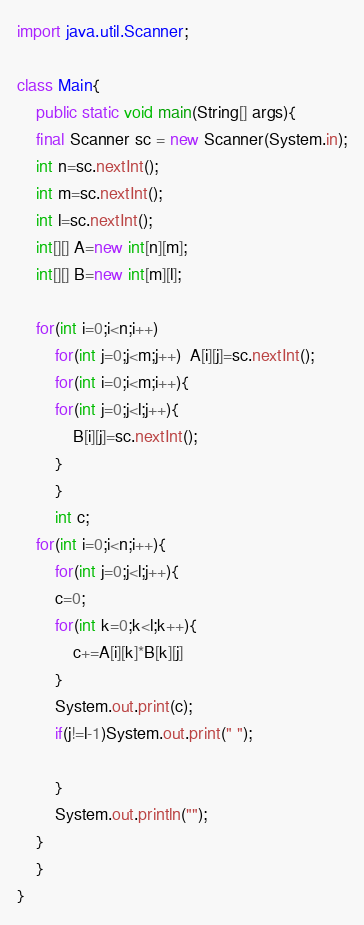Convert code to text. <code><loc_0><loc_0><loc_500><loc_500><_Java_>import java.util.Scanner;

class Main{
    public static void main(String[] args){
	final Scanner sc = new Scanner(System.in);
	int n=sc.nextInt();
	int m=sc.nextInt();
	int l=sc.nextInt();
	int[][] A=new int[n][m];
	int[][] B=new int[m][l];

	for(int i=0;i<n;i++)
	    for(int j=0;j<m;j++)  A[i][j]=sc.nextInt();
	    for(int i=0;i<m;i++){
		for(int j=0;j<l;j++){
		    B[i][j]=sc.nextInt();
		}
	    }
	    int c;
	for(int i=0;i<n;i++){
	    for(int j=0;j<l;j++){
		c=0;
		for(int k=0;k<l;k++){
		    c+=A[i][k]*B[k][j]
		}
		System.out.print(c);
		if(j!=l-1)System.out.print(" ");
		
	    }
	    System.out.println("");
	}
    }
}</code> 